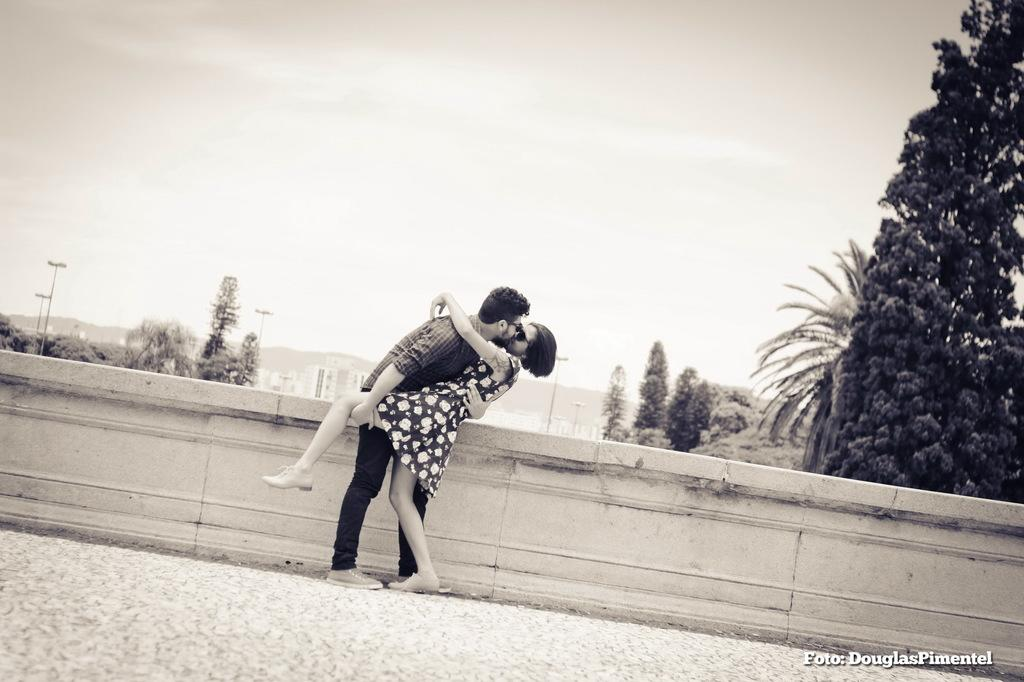How many people are present in the image? There are two people, a man and a woman, present in the image. What are the man and woman doing in the image? The man and woman are kissing each other in the image. What can be seen in the background of the image? There are trees, poles, buildings, and the sky visible in the background of the image. What type of lamp is hanging from the tree in the image? There is no lamp present in the image; it features a man and a woman kissing each other with various background elements. How many brothers are visible in the image? There is no mention of brothers in the image, as it only features a man and a woman. 